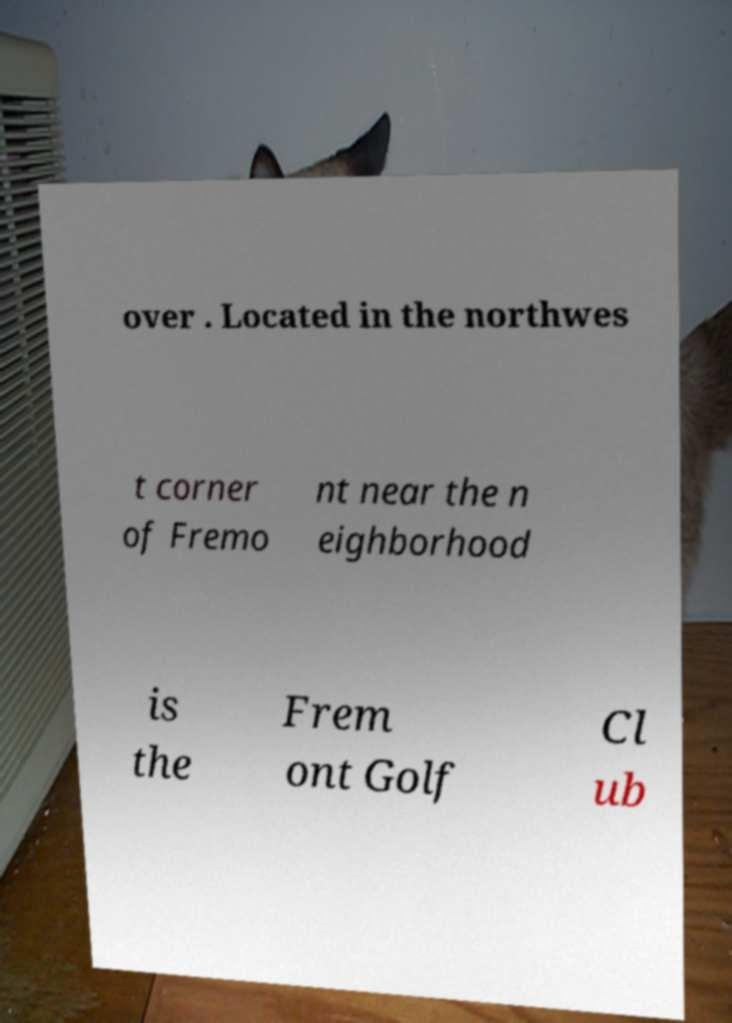Can you accurately transcribe the text from the provided image for me? over . Located in the northwes t corner of Fremo nt near the n eighborhood is the Frem ont Golf Cl ub 